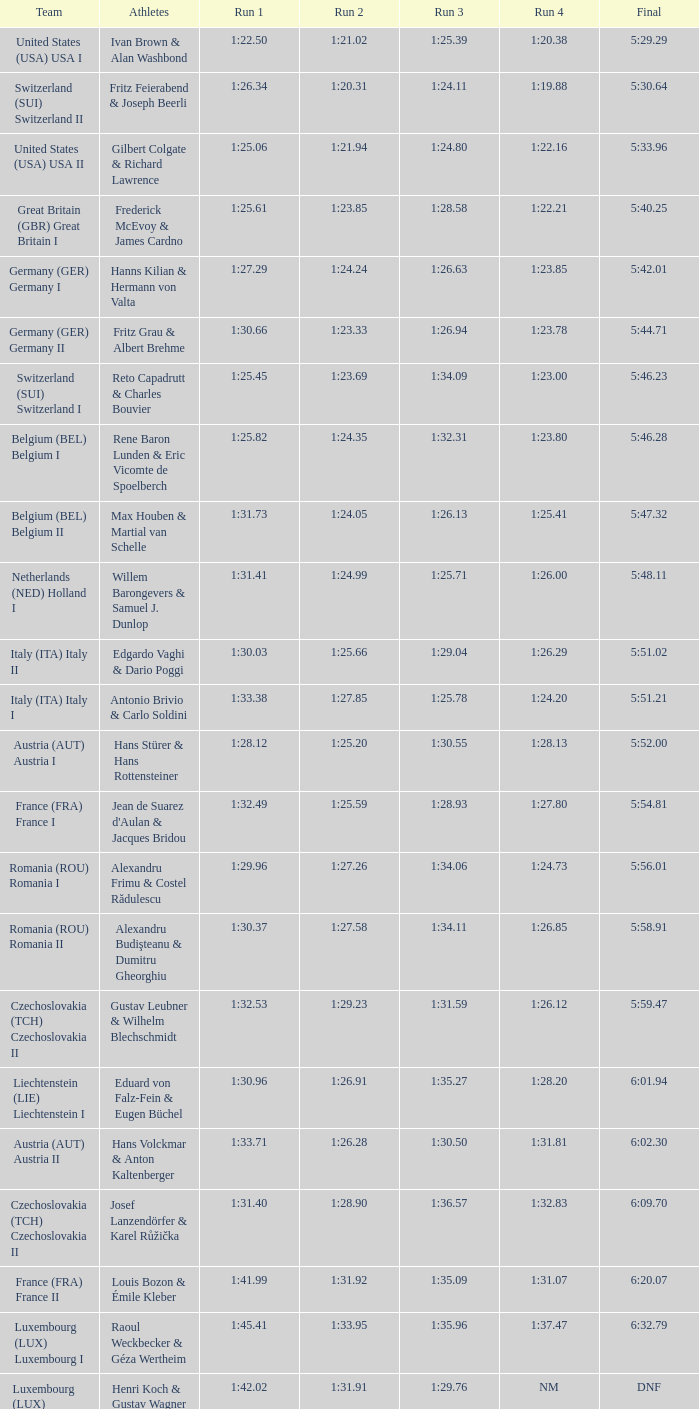82? 1:23.80. 